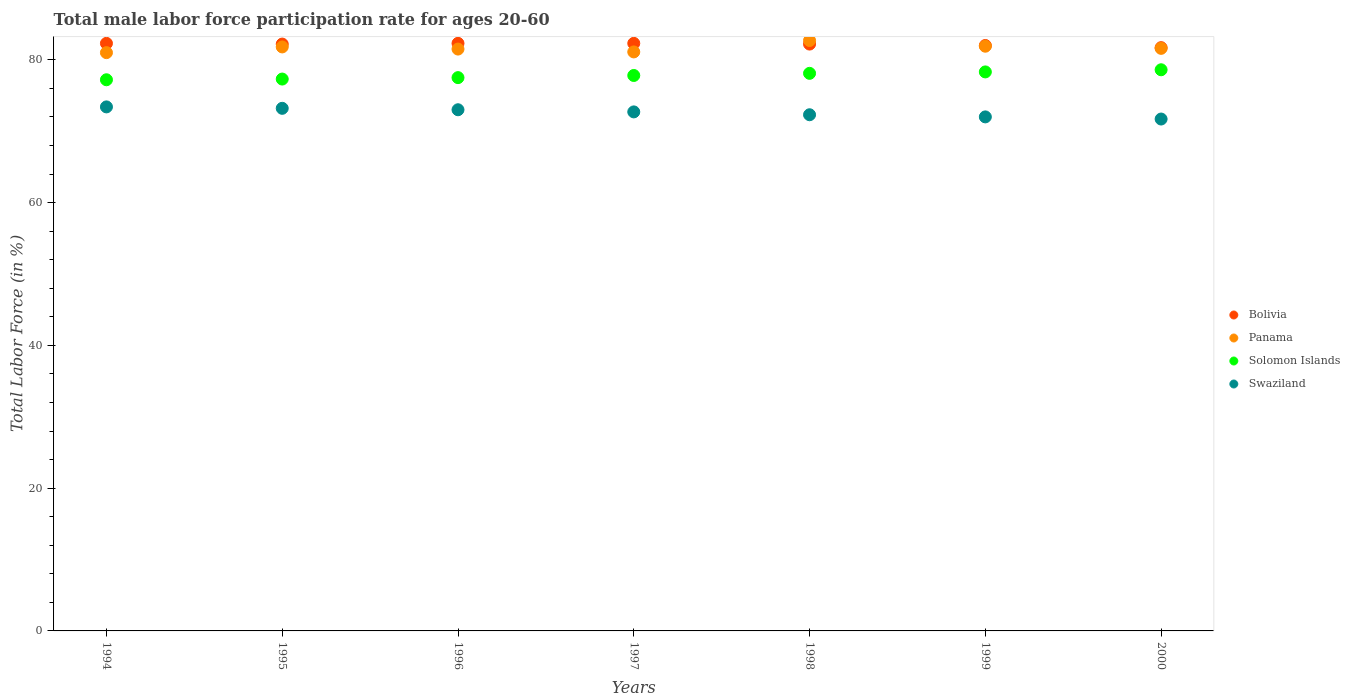Is the number of dotlines equal to the number of legend labels?
Offer a terse response. Yes. What is the male labor force participation rate in Solomon Islands in 1997?
Offer a terse response. 77.8. Across all years, what is the maximum male labor force participation rate in Panama?
Offer a very short reply. 82.7. What is the total male labor force participation rate in Panama in the graph?
Give a very brief answer. 571.6. What is the difference between the male labor force participation rate in Swaziland in 1996 and that in 2000?
Offer a very short reply. 1.3. What is the difference between the male labor force participation rate in Solomon Islands in 1998 and the male labor force participation rate in Bolivia in 1997?
Your answer should be compact. -4.2. What is the average male labor force participation rate in Swaziland per year?
Make the answer very short. 72.61. In the year 1997, what is the difference between the male labor force participation rate in Solomon Islands and male labor force participation rate in Panama?
Provide a short and direct response. -3.3. What is the ratio of the male labor force participation rate in Bolivia in 1994 to that in 1999?
Offer a very short reply. 1. Is the male labor force participation rate in Solomon Islands in 1994 less than that in 1998?
Your answer should be very brief. Yes. Is the difference between the male labor force participation rate in Solomon Islands in 1995 and 1996 greater than the difference between the male labor force participation rate in Panama in 1995 and 1996?
Give a very brief answer. No. What is the difference between the highest and the second highest male labor force participation rate in Solomon Islands?
Ensure brevity in your answer.  0.3. What is the difference between the highest and the lowest male labor force participation rate in Panama?
Ensure brevity in your answer.  1.7. Is it the case that in every year, the sum of the male labor force participation rate in Swaziland and male labor force participation rate in Bolivia  is greater than the sum of male labor force participation rate in Panama and male labor force participation rate in Solomon Islands?
Ensure brevity in your answer.  No. Is it the case that in every year, the sum of the male labor force participation rate in Bolivia and male labor force participation rate in Panama  is greater than the male labor force participation rate in Swaziland?
Give a very brief answer. Yes. Is the male labor force participation rate in Solomon Islands strictly greater than the male labor force participation rate in Bolivia over the years?
Offer a terse response. No. How many years are there in the graph?
Make the answer very short. 7. How many legend labels are there?
Your answer should be compact. 4. How are the legend labels stacked?
Your response must be concise. Vertical. What is the title of the graph?
Make the answer very short. Total male labor force participation rate for ages 20-60. Does "Aruba" appear as one of the legend labels in the graph?
Your answer should be compact. No. What is the label or title of the X-axis?
Give a very brief answer. Years. What is the label or title of the Y-axis?
Ensure brevity in your answer.  Total Labor Force (in %). What is the Total Labor Force (in %) of Bolivia in 1994?
Give a very brief answer. 82.3. What is the Total Labor Force (in %) of Solomon Islands in 1994?
Offer a very short reply. 77.2. What is the Total Labor Force (in %) in Swaziland in 1994?
Offer a very short reply. 73.4. What is the Total Labor Force (in %) of Bolivia in 1995?
Make the answer very short. 82.2. What is the Total Labor Force (in %) of Panama in 1995?
Offer a very short reply. 81.8. What is the Total Labor Force (in %) of Solomon Islands in 1995?
Offer a very short reply. 77.3. What is the Total Labor Force (in %) in Swaziland in 1995?
Offer a very short reply. 73.2. What is the Total Labor Force (in %) of Bolivia in 1996?
Your answer should be very brief. 82.3. What is the Total Labor Force (in %) of Panama in 1996?
Your answer should be compact. 81.5. What is the Total Labor Force (in %) in Solomon Islands in 1996?
Your answer should be compact. 77.5. What is the Total Labor Force (in %) in Swaziland in 1996?
Ensure brevity in your answer.  73. What is the Total Labor Force (in %) of Bolivia in 1997?
Give a very brief answer. 82.3. What is the Total Labor Force (in %) of Panama in 1997?
Keep it short and to the point. 81.1. What is the Total Labor Force (in %) of Solomon Islands in 1997?
Provide a short and direct response. 77.8. What is the Total Labor Force (in %) of Swaziland in 1997?
Keep it short and to the point. 72.7. What is the Total Labor Force (in %) in Bolivia in 1998?
Provide a succinct answer. 82.2. What is the Total Labor Force (in %) of Panama in 1998?
Give a very brief answer. 82.7. What is the Total Labor Force (in %) in Solomon Islands in 1998?
Provide a short and direct response. 78.1. What is the Total Labor Force (in %) of Swaziland in 1998?
Keep it short and to the point. 72.3. What is the Total Labor Force (in %) of Panama in 1999?
Your answer should be compact. 81.9. What is the Total Labor Force (in %) in Solomon Islands in 1999?
Provide a succinct answer. 78.3. What is the Total Labor Force (in %) of Bolivia in 2000?
Ensure brevity in your answer.  81.7. What is the Total Labor Force (in %) in Panama in 2000?
Your answer should be compact. 81.6. What is the Total Labor Force (in %) in Solomon Islands in 2000?
Your answer should be compact. 78.6. What is the Total Labor Force (in %) in Swaziland in 2000?
Keep it short and to the point. 71.7. Across all years, what is the maximum Total Labor Force (in %) of Bolivia?
Your response must be concise. 82.3. Across all years, what is the maximum Total Labor Force (in %) in Panama?
Your answer should be compact. 82.7. Across all years, what is the maximum Total Labor Force (in %) of Solomon Islands?
Offer a terse response. 78.6. Across all years, what is the maximum Total Labor Force (in %) of Swaziland?
Offer a very short reply. 73.4. Across all years, what is the minimum Total Labor Force (in %) of Bolivia?
Offer a very short reply. 81.7. Across all years, what is the minimum Total Labor Force (in %) of Panama?
Give a very brief answer. 81. Across all years, what is the minimum Total Labor Force (in %) of Solomon Islands?
Offer a very short reply. 77.2. Across all years, what is the minimum Total Labor Force (in %) of Swaziland?
Ensure brevity in your answer.  71.7. What is the total Total Labor Force (in %) of Bolivia in the graph?
Offer a very short reply. 575. What is the total Total Labor Force (in %) of Panama in the graph?
Your response must be concise. 571.6. What is the total Total Labor Force (in %) of Solomon Islands in the graph?
Your response must be concise. 544.8. What is the total Total Labor Force (in %) of Swaziland in the graph?
Offer a terse response. 508.3. What is the difference between the Total Labor Force (in %) of Bolivia in 1994 and that in 1995?
Offer a very short reply. 0.1. What is the difference between the Total Labor Force (in %) in Solomon Islands in 1994 and that in 1995?
Make the answer very short. -0.1. What is the difference between the Total Labor Force (in %) in Swaziland in 1994 and that in 1995?
Ensure brevity in your answer.  0.2. What is the difference between the Total Labor Force (in %) in Solomon Islands in 1994 and that in 1996?
Make the answer very short. -0.3. What is the difference between the Total Labor Force (in %) in Swaziland in 1994 and that in 1996?
Give a very brief answer. 0.4. What is the difference between the Total Labor Force (in %) in Bolivia in 1994 and that in 1997?
Your answer should be very brief. 0. What is the difference between the Total Labor Force (in %) in Panama in 1994 and that in 1997?
Provide a short and direct response. -0.1. What is the difference between the Total Labor Force (in %) in Solomon Islands in 1994 and that in 1997?
Your answer should be compact. -0.6. What is the difference between the Total Labor Force (in %) of Swaziland in 1994 and that in 1997?
Provide a succinct answer. 0.7. What is the difference between the Total Labor Force (in %) of Solomon Islands in 1994 and that in 1998?
Ensure brevity in your answer.  -0.9. What is the difference between the Total Labor Force (in %) of Swaziland in 1994 and that in 1999?
Ensure brevity in your answer.  1.4. What is the difference between the Total Labor Force (in %) of Bolivia in 1994 and that in 2000?
Offer a very short reply. 0.6. What is the difference between the Total Labor Force (in %) in Solomon Islands in 1994 and that in 2000?
Provide a succinct answer. -1.4. What is the difference between the Total Labor Force (in %) in Swaziland in 1994 and that in 2000?
Give a very brief answer. 1.7. What is the difference between the Total Labor Force (in %) in Solomon Islands in 1995 and that in 1996?
Provide a short and direct response. -0.2. What is the difference between the Total Labor Force (in %) of Panama in 1995 and that in 1997?
Provide a succinct answer. 0.7. What is the difference between the Total Labor Force (in %) in Solomon Islands in 1995 and that in 1997?
Your answer should be compact. -0.5. What is the difference between the Total Labor Force (in %) of Bolivia in 1995 and that in 1998?
Offer a very short reply. 0. What is the difference between the Total Labor Force (in %) of Solomon Islands in 1995 and that in 1998?
Your answer should be very brief. -0.8. What is the difference between the Total Labor Force (in %) of Bolivia in 1995 and that in 1999?
Offer a very short reply. 0.2. What is the difference between the Total Labor Force (in %) of Solomon Islands in 1995 and that in 1999?
Make the answer very short. -1. What is the difference between the Total Labor Force (in %) in Bolivia in 1995 and that in 2000?
Offer a terse response. 0.5. What is the difference between the Total Labor Force (in %) of Bolivia in 1996 and that in 1997?
Your response must be concise. 0. What is the difference between the Total Labor Force (in %) of Solomon Islands in 1996 and that in 1997?
Ensure brevity in your answer.  -0.3. What is the difference between the Total Labor Force (in %) in Bolivia in 1996 and that in 1998?
Offer a terse response. 0.1. What is the difference between the Total Labor Force (in %) of Solomon Islands in 1996 and that in 1998?
Ensure brevity in your answer.  -0.6. What is the difference between the Total Labor Force (in %) in Bolivia in 1996 and that in 1999?
Make the answer very short. 0.3. What is the difference between the Total Labor Force (in %) of Solomon Islands in 1996 and that in 1999?
Ensure brevity in your answer.  -0.8. What is the difference between the Total Labor Force (in %) in Bolivia in 1996 and that in 2000?
Your answer should be very brief. 0.6. What is the difference between the Total Labor Force (in %) in Panama in 1996 and that in 2000?
Offer a very short reply. -0.1. What is the difference between the Total Labor Force (in %) in Solomon Islands in 1996 and that in 2000?
Your response must be concise. -1.1. What is the difference between the Total Labor Force (in %) in Swaziland in 1996 and that in 2000?
Provide a short and direct response. 1.3. What is the difference between the Total Labor Force (in %) in Bolivia in 1997 and that in 1998?
Give a very brief answer. 0.1. What is the difference between the Total Labor Force (in %) in Solomon Islands in 1997 and that in 1998?
Your answer should be very brief. -0.3. What is the difference between the Total Labor Force (in %) of Swaziland in 1997 and that in 1998?
Your answer should be compact. 0.4. What is the difference between the Total Labor Force (in %) of Bolivia in 1997 and that in 1999?
Offer a very short reply. 0.3. What is the difference between the Total Labor Force (in %) in Panama in 1997 and that in 1999?
Offer a terse response. -0.8. What is the difference between the Total Labor Force (in %) of Solomon Islands in 1997 and that in 1999?
Offer a terse response. -0.5. What is the difference between the Total Labor Force (in %) in Swaziland in 1997 and that in 1999?
Your answer should be very brief. 0.7. What is the difference between the Total Labor Force (in %) of Bolivia in 1997 and that in 2000?
Give a very brief answer. 0.6. What is the difference between the Total Labor Force (in %) in Panama in 1997 and that in 2000?
Ensure brevity in your answer.  -0.5. What is the difference between the Total Labor Force (in %) of Swaziland in 1997 and that in 2000?
Keep it short and to the point. 1. What is the difference between the Total Labor Force (in %) of Bolivia in 1998 and that in 1999?
Your answer should be compact. 0.2. What is the difference between the Total Labor Force (in %) of Panama in 1998 and that in 1999?
Your answer should be very brief. 0.8. What is the difference between the Total Labor Force (in %) of Solomon Islands in 1998 and that in 1999?
Ensure brevity in your answer.  -0.2. What is the difference between the Total Labor Force (in %) in Bolivia in 1998 and that in 2000?
Make the answer very short. 0.5. What is the difference between the Total Labor Force (in %) of Solomon Islands in 1998 and that in 2000?
Offer a very short reply. -0.5. What is the difference between the Total Labor Force (in %) of Panama in 1999 and that in 2000?
Offer a terse response. 0.3. What is the difference between the Total Labor Force (in %) in Solomon Islands in 1999 and that in 2000?
Give a very brief answer. -0.3. What is the difference between the Total Labor Force (in %) of Swaziland in 1999 and that in 2000?
Offer a very short reply. 0.3. What is the difference between the Total Labor Force (in %) of Bolivia in 1994 and the Total Labor Force (in %) of Panama in 1995?
Make the answer very short. 0.5. What is the difference between the Total Labor Force (in %) of Bolivia in 1994 and the Total Labor Force (in %) of Solomon Islands in 1995?
Ensure brevity in your answer.  5. What is the difference between the Total Labor Force (in %) in Bolivia in 1994 and the Total Labor Force (in %) in Swaziland in 1995?
Give a very brief answer. 9.1. What is the difference between the Total Labor Force (in %) in Panama in 1994 and the Total Labor Force (in %) in Solomon Islands in 1995?
Your answer should be compact. 3.7. What is the difference between the Total Labor Force (in %) in Panama in 1994 and the Total Labor Force (in %) in Swaziland in 1995?
Provide a short and direct response. 7.8. What is the difference between the Total Labor Force (in %) of Solomon Islands in 1994 and the Total Labor Force (in %) of Swaziland in 1995?
Offer a very short reply. 4. What is the difference between the Total Labor Force (in %) in Bolivia in 1994 and the Total Labor Force (in %) in Panama in 1996?
Offer a very short reply. 0.8. What is the difference between the Total Labor Force (in %) in Bolivia in 1994 and the Total Labor Force (in %) in Solomon Islands in 1996?
Keep it short and to the point. 4.8. What is the difference between the Total Labor Force (in %) of Panama in 1994 and the Total Labor Force (in %) of Solomon Islands in 1996?
Give a very brief answer. 3.5. What is the difference between the Total Labor Force (in %) in Panama in 1994 and the Total Labor Force (in %) in Swaziland in 1996?
Your response must be concise. 8. What is the difference between the Total Labor Force (in %) in Bolivia in 1994 and the Total Labor Force (in %) in Swaziland in 1997?
Your response must be concise. 9.6. What is the difference between the Total Labor Force (in %) of Panama in 1994 and the Total Labor Force (in %) of Solomon Islands in 1997?
Your answer should be very brief. 3.2. What is the difference between the Total Labor Force (in %) of Bolivia in 1994 and the Total Labor Force (in %) of Solomon Islands in 1998?
Ensure brevity in your answer.  4.2. What is the difference between the Total Labor Force (in %) of Bolivia in 1994 and the Total Labor Force (in %) of Swaziland in 1999?
Make the answer very short. 10.3. What is the difference between the Total Labor Force (in %) of Bolivia in 1994 and the Total Labor Force (in %) of Solomon Islands in 2000?
Keep it short and to the point. 3.7. What is the difference between the Total Labor Force (in %) of Bolivia in 1994 and the Total Labor Force (in %) of Swaziland in 2000?
Your answer should be very brief. 10.6. What is the difference between the Total Labor Force (in %) of Panama in 1994 and the Total Labor Force (in %) of Solomon Islands in 2000?
Ensure brevity in your answer.  2.4. What is the difference between the Total Labor Force (in %) of Panama in 1994 and the Total Labor Force (in %) of Swaziland in 2000?
Your response must be concise. 9.3. What is the difference between the Total Labor Force (in %) in Solomon Islands in 1994 and the Total Labor Force (in %) in Swaziland in 2000?
Provide a short and direct response. 5.5. What is the difference between the Total Labor Force (in %) in Bolivia in 1995 and the Total Labor Force (in %) in Swaziland in 1996?
Your answer should be compact. 9.2. What is the difference between the Total Labor Force (in %) of Panama in 1995 and the Total Labor Force (in %) of Swaziland in 1996?
Offer a very short reply. 8.8. What is the difference between the Total Labor Force (in %) of Bolivia in 1995 and the Total Labor Force (in %) of Solomon Islands in 1997?
Your answer should be compact. 4.4. What is the difference between the Total Labor Force (in %) in Panama in 1995 and the Total Labor Force (in %) in Swaziland in 1997?
Make the answer very short. 9.1. What is the difference between the Total Labor Force (in %) of Solomon Islands in 1995 and the Total Labor Force (in %) of Swaziland in 1997?
Your answer should be compact. 4.6. What is the difference between the Total Labor Force (in %) in Bolivia in 1995 and the Total Labor Force (in %) in Panama in 1998?
Provide a succinct answer. -0.5. What is the difference between the Total Labor Force (in %) in Panama in 1995 and the Total Labor Force (in %) in Swaziland in 1999?
Keep it short and to the point. 9.8. What is the difference between the Total Labor Force (in %) in Bolivia in 1995 and the Total Labor Force (in %) in Solomon Islands in 2000?
Offer a very short reply. 3.6. What is the difference between the Total Labor Force (in %) in Panama in 1995 and the Total Labor Force (in %) in Swaziland in 2000?
Offer a very short reply. 10.1. What is the difference between the Total Labor Force (in %) in Solomon Islands in 1995 and the Total Labor Force (in %) in Swaziland in 2000?
Provide a short and direct response. 5.6. What is the difference between the Total Labor Force (in %) of Bolivia in 1996 and the Total Labor Force (in %) of Panama in 1997?
Your answer should be compact. 1.2. What is the difference between the Total Labor Force (in %) of Solomon Islands in 1996 and the Total Labor Force (in %) of Swaziland in 1997?
Give a very brief answer. 4.8. What is the difference between the Total Labor Force (in %) in Bolivia in 1996 and the Total Labor Force (in %) in Panama in 1998?
Offer a very short reply. -0.4. What is the difference between the Total Labor Force (in %) of Bolivia in 1996 and the Total Labor Force (in %) of Swaziland in 1998?
Ensure brevity in your answer.  10. What is the difference between the Total Labor Force (in %) of Panama in 1996 and the Total Labor Force (in %) of Solomon Islands in 1998?
Keep it short and to the point. 3.4. What is the difference between the Total Labor Force (in %) in Panama in 1996 and the Total Labor Force (in %) in Swaziland in 1998?
Provide a succinct answer. 9.2. What is the difference between the Total Labor Force (in %) in Bolivia in 1996 and the Total Labor Force (in %) in Panama in 1999?
Make the answer very short. 0.4. What is the difference between the Total Labor Force (in %) in Panama in 1996 and the Total Labor Force (in %) in Solomon Islands in 1999?
Your response must be concise. 3.2. What is the difference between the Total Labor Force (in %) of Panama in 1996 and the Total Labor Force (in %) of Swaziland in 1999?
Keep it short and to the point. 9.5. What is the difference between the Total Labor Force (in %) in Solomon Islands in 1996 and the Total Labor Force (in %) in Swaziland in 1999?
Your response must be concise. 5.5. What is the difference between the Total Labor Force (in %) in Bolivia in 1996 and the Total Labor Force (in %) in Solomon Islands in 2000?
Your response must be concise. 3.7. What is the difference between the Total Labor Force (in %) of Panama in 1996 and the Total Labor Force (in %) of Solomon Islands in 2000?
Offer a terse response. 2.9. What is the difference between the Total Labor Force (in %) of Panama in 1996 and the Total Labor Force (in %) of Swaziland in 2000?
Provide a short and direct response. 9.8. What is the difference between the Total Labor Force (in %) of Bolivia in 1997 and the Total Labor Force (in %) of Panama in 1998?
Your response must be concise. -0.4. What is the difference between the Total Labor Force (in %) of Panama in 1997 and the Total Labor Force (in %) of Solomon Islands in 1998?
Provide a short and direct response. 3. What is the difference between the Total Labor Force (in %) of Bolivia in 1997 and the Total Labor Force (in %) of Panama in 1999?
Provide a succinct answer. 0.4. What is the difference between the Total Labor Force (in %) of Bolivia in 1997 and the Total Labor Force (in %) of Solomon Islands in 1999?
Keep it short and to the point. 4. What is the difference between the Total Labor Force (in %) in Bolivia in 1997 and the Total Labor Force (in %) in Swaziland in 1999?
Give a very brief answer. 10.3. What is the difference between the Total Labor Force (in %) of Panama in 1997 and the Total Labor Force (in %) of Swaziland in 1999?
Your response must be concise. 9.1. What is the difference between the Total Labor Force (in %) of Bolivia in 1997 and the Total Labor Force (in %) of Swaziland in 2000?
Offer a terse response. 10.6. What is the difference between the Total Labor Force (in %) in Solomon Islands in 1997 and the Total Labor Force (in %) in Swaziland in 2000?
Offer a very short reply. 6.1. What is the difference between the Total Labor Force (in %) in Bolivia in 1998 and the Total Labor Force (in %) in Panama in 2000?
Offer a terse response. 0.6. What is the difference between the Total Labor Force (in %) of Bolivia in 1998 and the Total Labor Force (in %) of Swaziland in 2000?
Your answer should be compact. 10.5. What is the difference between the Total Labor Force (in %) in Panama in 1998 and the Total Labor Force (in %) in Solomon Islands in 2000?
Your answer should be compact. 4.1. What is the difference between the Total Labor Force (in %) of Panama in 1998 and the Total Labor Force (in %) of Swaziland in 2000?
Offer a very short reply. 11. What is the difference between the Total Labor Force (in %) of Solomon Islands in 1998 and the Total Labor Force (in %) of Swaziland in 2000?
Give a very brief answer. 6.4. What is the difference between the Total Labor Force (in %) of Bolivia in 1999 and the Total Labor Force (in %) of Solomon Islands in 2000?
Provide a succinct answer. 3.4. What is the difference between the Total Labor Force (in %) in Panama in 1999 and the Total Labor Force (in %) in Solomon Islands in 2000?
Your answer should be very brief. 3.3. What is the difference between the Total Labor Force (in %) in Panama in 1999 and the Total Labor Force (in %) in Swaziland in 2000?
Offer a very short reply. 10.2. What is the average Total Labor Force (in %) in Bolivia per year?
Give a very brief answer. 82.14. What is the average Total Labor Force (in %) of Panama per year?
Your response must be concise. 81.66. What is the average Total Labor Force (in %) of Solomon Islands per year?
Your response must be concise. 77.83. What is the average Total Labor Force (in %) of Swaziland per year?
Offer a terse response. 72.61. In the year 1994, what is the difference between the Total Labor Force (in %) of Bolivia and Total Labor Force (in %) of Panama?
Offer a very short reply. 1.3. In the year 1994, what is the difference between the Total Labor Force (in %) of Bolivia and Total Labor Force (in %) of Solomon Islands?
Offer a terse response. 5.1. In the year 1994, what is the difference between the Total Labor Force (in %) in Panama and Total Labor Force (in %) in Solomon Islands?
Your answer should be compact. 3.8. In the year 1995, what is the difference between the Total Labor Force (in %) of Bolivia and Total Labor Force (in %) of Panama?
Your response must be concise. 0.4. In the year 1995, what is the difference between the Total Labor Force (in %) of Bolivia and Total Labor Force (in %) of Solomon Islands?
Give a very brief answer. 4.9. In the year 1995, what is the difference between the Total Labor Force (in %) of Bolivia and Total Labor Force (in %) of Swaziland?
Your answer should be very brief. 9. In the year 1995, what is the difference between the Total Labor Force (in %) of Panama and Total Labor Force (in %) of Solomon Islands?
Your response must be concise. 4.5. In the year 1995, what is the difference between the Total Labor Force (in %) of Panama and Total Labor Force (in %) of Swaziland?
Offer a very short reply. 8.6. In the year 1996, what is the difference between the Total Labor Force (in %) in Bolivia and Total Labor Force (in %) in Swaziland?
Keep it short and to the point. 9.3. In the year 1996, what is the difference between the Total Labor Force (in %) in Panama and Total Labor Force (in %) in Solomon Islands?
Give a very brief answer. 4. In the year 1996, what is the difference between the Total Labor Force (in %) in Panama and Total Labor Force (in %) in Swaziland?
Make the answer very short. 8.5. In the year 1997, what is the difference between the Total Labor Force (in %) of Bolivia and Total Labor Force (in %) of Panama?
Keep it short and to the point. 1.2. In the year 1997, what is the difference between the Total Labor Force (in %) in Panama and Total Labor Force (in %) in Solomon Islands?
Your answer should be compact. 3.3. In the year 1998, what is the difference between the Total Labor Force (in %) of Bolivia and Total Labor Force (in %) of Solomon Islands?
Make the answer very short. 4.1. In the year 1998, what is the difference between the Total Labor Force (in %) in Panama and Total Labor Force (in %) in Swaziland?
Provide a succinct answer. 10.4. In the year 1998, what is the difference between the Total Labor Force (in %) in Solomon Islands and Total Labor Force (in %) in Swaziland?
Offer a terse response. 5.8. In the year 1999, what is the difference between the Total Labor Force (in %) in Bolivia and Total Labor Force (in %) in Solomon Islands?
Provide a succinct answer. 3.7. In the year 2000, what is the difference between the Total Labor Force (in %) in Bolivia and Total Labor Force (in %) in Solomon Islands?
Provide a succinct answer. 3.1. In the year 2000, what is the difference between the Total Labor Force (in %) in Bolivia and Total Labor Force (in %) in Swaziland?
Keep it short and to the point. 10. In the year 2000, what is the difference between the Total Labor Force (in %) in Panama and Total Labor Force (in %) in Swaziland?
Offer a terse response. 9.9. What is the ratio of the Total Labor Force (in %) of Bolivia in 1994 to that in 1995?
Provide a succinct answer. 1. What is the ratio of the Total Labor Force (in %) of Panama in 1994 to that in 1995?
Make the answer very short. 0.99. What is the ratio of the Total Labor Force (in %) in Swaziland in 1994 to that in 1995?
Make the answer very short. 1. What is the ratio of the Total Labor Force (in %) of Bolivia in 1994 to that in 1996?
Keep it short and to the point. 1. What is the ratio of the Total Labor Force (in %) of Bolivia in 1994 to that in 1997?
Keep it short and to the point. 1. What is the ratio of the Total Labor Force (in %) of Panama in 1994 to that in 1997?
Offer a very short reply. 1. What is the ratio of the Total Labor Force (in %) in Solomon Islands in 1994 to that in 1997?
Offer a very short reply. 0.99. What is the ratio of the Total Labor Force (in %) of Swaziland in 1994 to that in 1997?
Your answer should be compact. 1.01. What is the ratio of the Total Labor Force (in %) of Bolivia in 1994 to that in 1998?
Make the answer very short. 1. What is the ratio of the Total Labor Force (in %) of Panama in 1994 to that in 1998?
Keep it short and to the point. 0.98. What is the ratio of the Total Labor Force (in %) of Solomon Islands in 1994 to that in 1998?
Provide a succinct answer. 0.99. What is the ratio of the Total Labor Force (in %) in Swaziland in 1994 to that in 1998?
Make the answer very short. 1.02. What is the ratio of the Total Labor Force (in %) of Panama in 1994 to that in 1999?
Make the answer very short. 0.99. What is the ratio of the Total Labor Force (in %) in Swaziland in 1994 to that in 1999?
Your response must be concise. 1.02. What is the ratio of the Total Labor Force (in %) in Bolivia in 1994 to that in 2000?
Ensure brevity in your answer.  1.01. What is the ratio of the Total Labor Force (in %) of Panama in 1994 to that in 2000?
Your answer should be very brief. 0.99. What is the ratio of the Total Labor Force (in %) of Solomon Islands in 1994 to that in 2000?
Give a very brief answer. 0.98. What is the ratio of the Total Labor Force (in %) in Swaziland in 1994 to that in 2000?
Your response must be concise. 1.02. What is the ratio of the Total Labor Force (in %) of Bolivia in 1995 to that in 1996?
Offer a very short reply. 1. What is the ratio of the Total Labor Force (in %) in Solomon Islands in 1995 to that in 1996?
Keep it short and to the point. 1. What is the ratio of the Total Labor Force (in %) of Swaziland in 1995 to that in 1996?
Your answer should be compact. 1. What is the ratio of the Total Labor Force (in %) in Panama in 1995 to that in 1997?
Your response must be concise. 1.01. What is the ratio of the Total Labor Force (in %) of Solomon Islands in 1995 to that in 1997?
Your response must be concise. 0.99. What is the ratio of the Total Labor Force (in %) in Solomon Islands in 1995 to that in 1998?
Ensure brevity in your answer.  0.99. What is the ratio of the Total Labor Force (in %) of Swaziland in 1995 to that in 1998?
Provide a short and direct response. 1.01. What is the ratio of the Total Labor Force (in %) of Bolivia in 1995 to that in 1999?
Keep it short and to the point. 1. What is the ratio of the Total Labor Force (in %) in Solomon Islands in 1995 to that in 1999?
Provide a short and direct response. 0.99. What is the ratio of the Total Labor Force (in %) in Swaziland in 1995 to that in 1999?
Offer a very short reply. 1.02. What is the ratio of the Total Labor Force (in %) of Panama in 1995 to that in 2000?
Your answer should be very brief. 1. What is the ratio of the Total Labor Force (in %) of Solomon Islands in 1995 to that in 2000?
Keep it short and to the point. 0.98. What is the ratio of the Total Labor Force (in %) of Swaziland in 1995 to that in 2000?
Give a very brief answer. 1.02. What is the ratio of the Total Labor Force (in %) in Bolivia in 1996 to that in 1997?
Offer a terse response. 1. What is the ratio of the Total Labor Force (in %) of Panama in 1996 to that in 1998?
Keep it short and to the point. 0.99. What is the ratio of the Total Labor Force (in %) in Solomon Islands in 1996 to that in 1998?
Provide a succinct answer. 0.99. What is the ratio of the Total Labor Force (in %) in Swaziland in 1996 to that in 1998?
Give a very brief answer. 1.01. What is the ratio of the Total Labor Force (in %) of Bolivia in 1996 to that in 1999?
Ensure brevity in your answer.  1. What is the ratio of the Total Labor Force (in %) in Panama in 1996 to that in 1999?
Ensure brevity in your answer.  1. What is the ratio of the Total Labor Force (in %) in Swaziland in 1996 to that in 1999?
Your answer should be very brief. 1.01. What is the ratio of the Total Labor Force (in %) of Bolivia in 1996 to that in 2000?
Offer a terse response. 1.01. What is the ratio of the Total Labor Force (in %) in Panama in 1996 to that in 2000?
Provide a short and direct response. 1. What is the ratio of the Total Labor Force (in %) in Swaziland in 1996 to that in 2000?
Provide a succinct answer. 1.02. What is the ratio of the Total Labor Force (in %) of Bolivia in 1997 to that in 1998?
Provide a succinct answer. 1. What is the ratio of the Total Labor Force (in %) in Panama in 1997 to that in 1998?
Provide a succinct answer. 0.98. What is the ratio of the Total Labor Force (in %) in Swaziland in 1997 to that in 1998?
Offer a very short reply. 1.01. What is the ratio of the Total Labor Force (in %) of Panama in 1997 to that in 1999?
Provide a succinct answer. 0.99. What is the ratio of the Total Labor Force (in %) in Solomon Islands in 1997 to that in 1999?
Give a very brief answer. 0.99. What is the ratio of the Total Labor Force (in %) in Swaziland in 1997 to that in 1999?
Offer a very short reply. 1.01. What is the ratio of the Total Labor Force (in %) in Bolivia in 1997 to that in 2000?
Offer a very short reply. 1.01. What is the ratio of the Total Labor Force (in %) in Panama in 1997 to that in 2000?
Offer a terse response. 0.99. What is the ratio of the Total Labor Force (in %) in Solomon Islands in 1997 to that in 2000?
Make the answer very short. 0.99. What is the ratio of the Total Labor Force (in %) in Swaziland in 1997 to that in 2000?
Your answer should be compact. 1.01. What is the ratio of the Total Labor Force (in %) of Panama in 1998 to that in 1999?
Offer a very short reply. 1.01. What is the ratio of the Total Labor Force (in %) of Solomon Islands in 1998 to that in 1999?
Offer a very short reply. 1. What is the ratio of the Total Labor Force (in %) in Panama in 1998 to that in 2000?
Your answer should be very brief. 1.01. What is the ratio of the Total Labor Force (in %) in Swaziland in 1998 to that in 2000?
Make the answer very short. 1.01. What is the ratio of the Total Labor Force (in %) of Bolivia in 1999 to that in 2000?
Ensure brevity in your answer.  1. What is the ratio of the Total Labor Force (in %) in Panama in 1999 to that in 2000?
Provide a succinct answer. 1. What is the difference between the highest and the second highest Total Labor Force (in %) of Bolivia?
Provide a short and direct response. 0. What is the difference between the highest and the second highest Total Labor Force (in %) in Swaziland?
Offer a very short reply. 0.2. What is the difference between the highest and the lowest Total Labor Force (in %) in Solomon Islands?
Give a very brief answer. 1.4. 